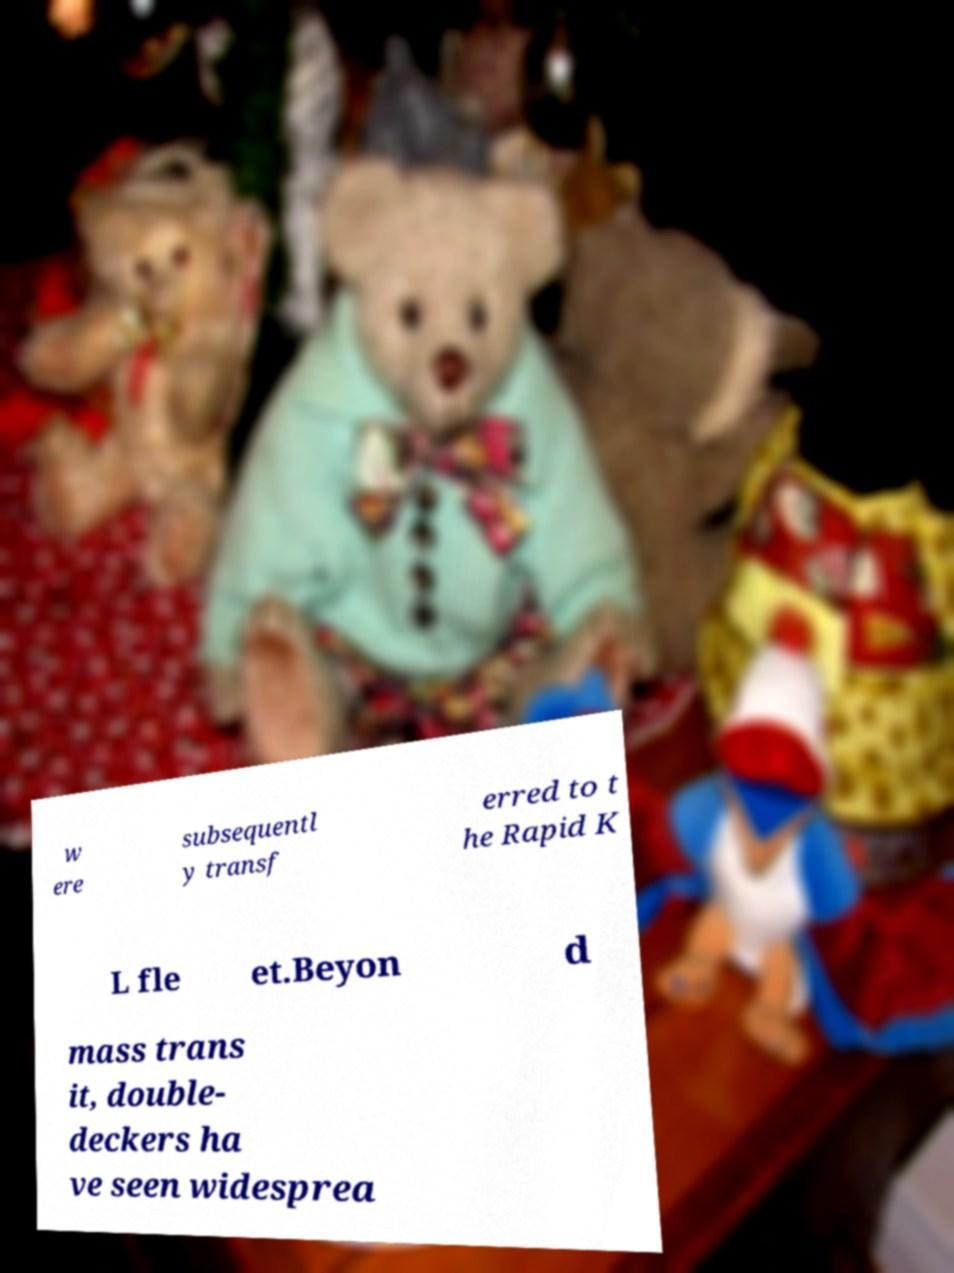Can you read and provide the text displayed in the image?This photo seems to have some interesting text. Can you extract and type it out for me? w ere subsequentl y transf erred to t he Rapid K L fle et.Beyon d mass trans it, double- deckers ha ve seen widesprea 